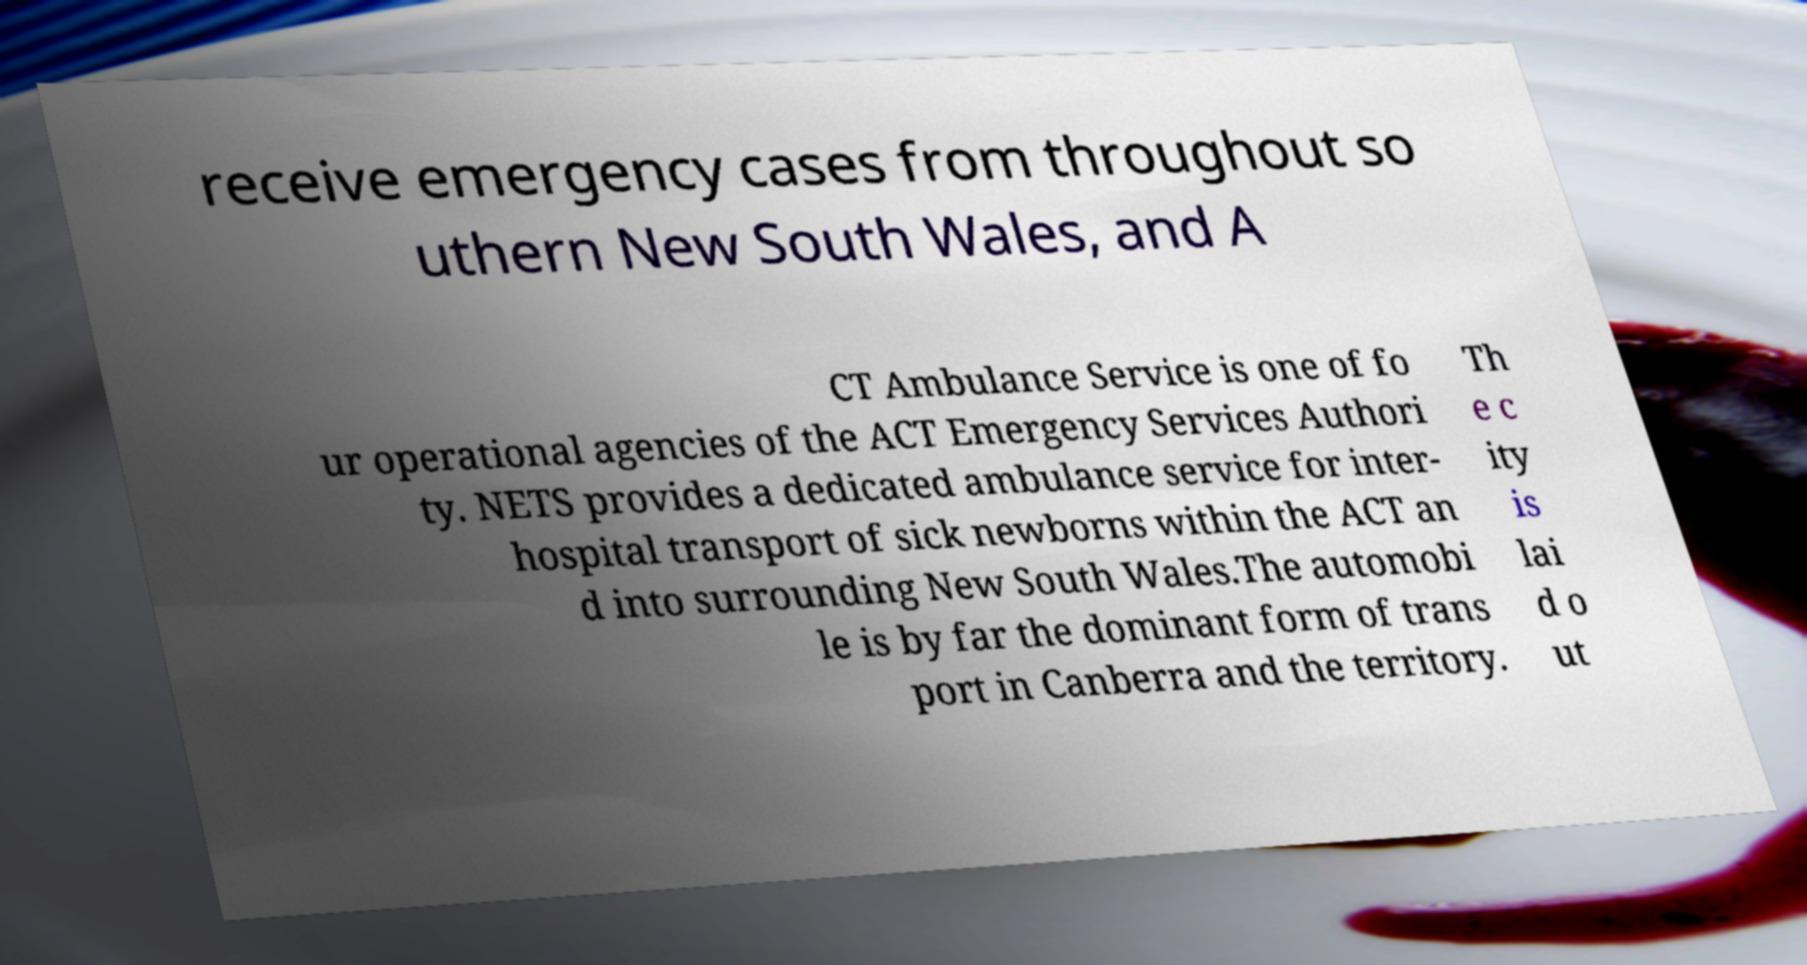What messages or text are displayed in this image? I need them in a readable, typed format. receive emergency cases from throughout so uthern New South Wales, and A CT Ambulance Service is one of fo ur operational agencies of the ACT Emergency Services Authori ty. NETS provides a dedicated ambulance service for inter- hospital transport of sick newborns within the ACT an d into surrounding New South Wales.The automobi le is by far the dominant form of trans port in Canberra and the territory. Th e c ity is lai d o ut 